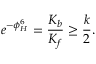<formula> <loc_0><loc_0><loc_500><loc_500>e ^ { - \phi _ { H } ^ { 6 } } = { \frac { K _ { b } } { K _ { f } } } \geq { \frac { k } { 2 } } .</formula> 